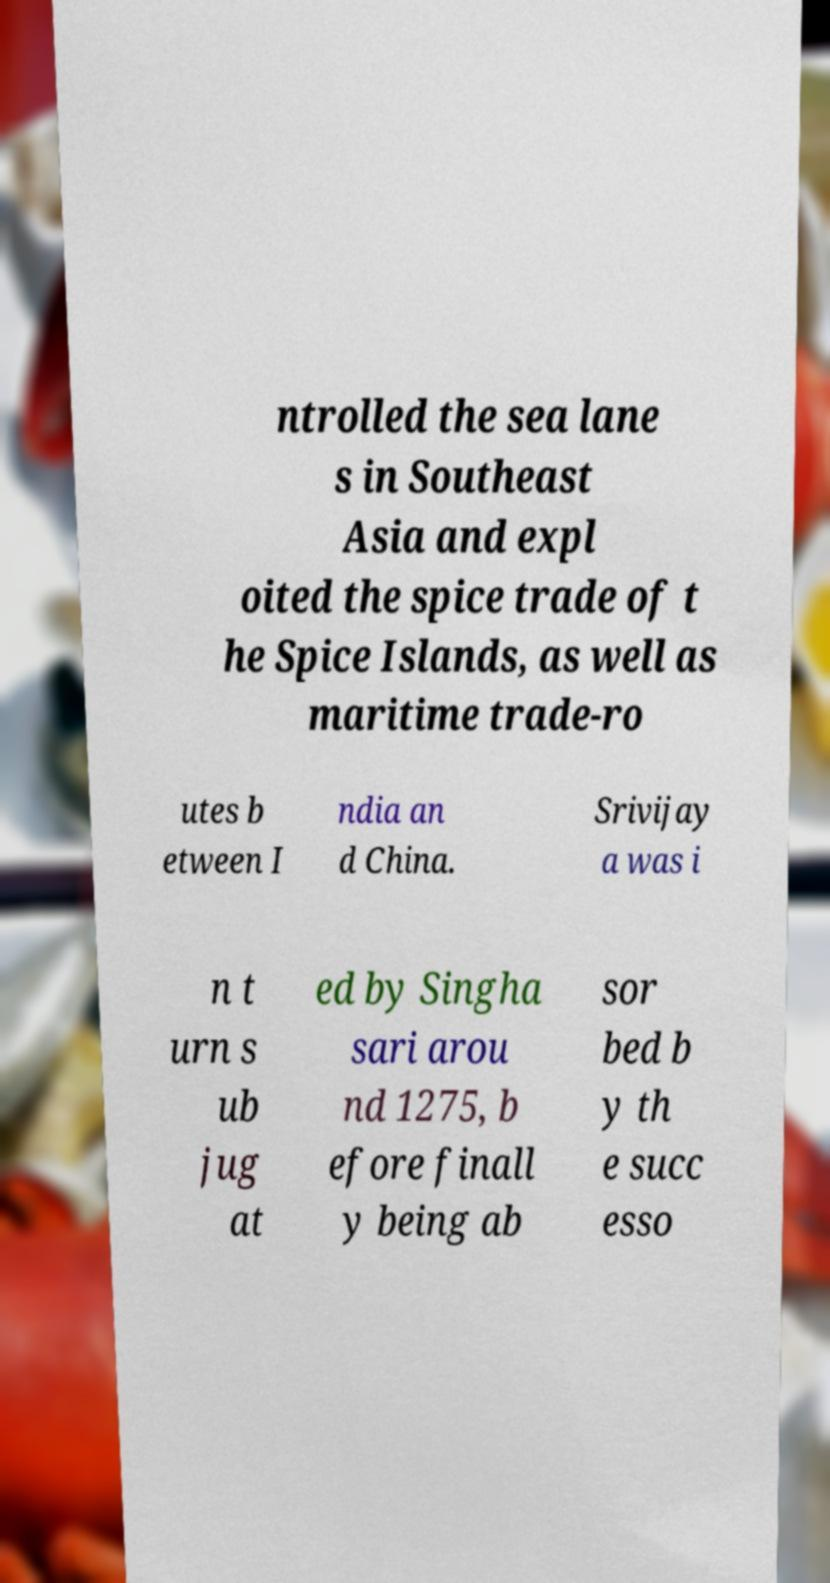Could you assist in decoding the text presented in this image and type it out clearly? ntrolled the sea lane s in Southeast Asia and expl oited the spice trade of t he Spice Islands, as well as maritime trade-ro utes b etween I ndia an d China. Srivijay a was i n t urn s ub jug at ed by Singha sari arou nd 1275, b efore finall y being ab sor bed b y th e succ esso 